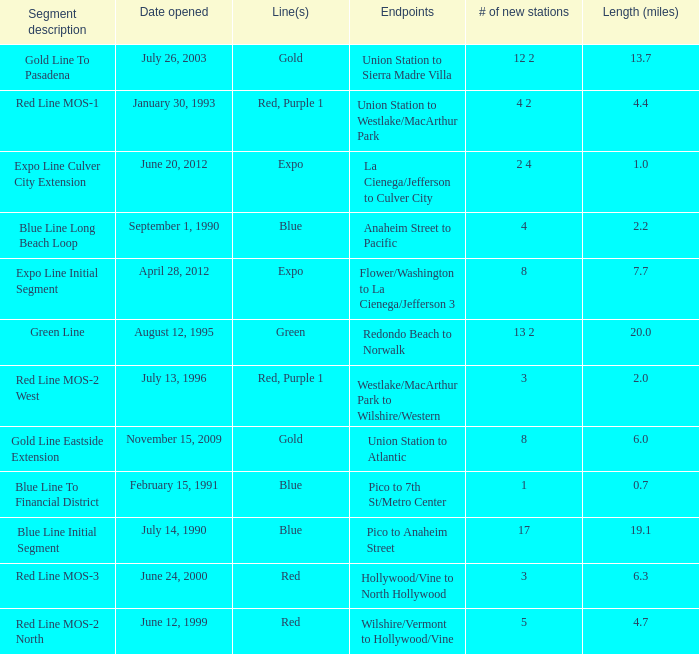How many new stations have a lenght (miles) of 6.0? 1.0. Would you mind parsing the complete table? {'header': ['Segment description', 'Date opened', 'Line(s)', 'Endpoints', '# of new stations', 'Length (miles)'], 'rows': [['Gold Line To Pasadena', 'July 26, 2003', 'Gold', 'Union Station to Sierra Madre Villa', '12 2', '13.7'], ['Red Line MOS-1', 'January 30, 1993', 'Red, Purple 1', 'Union Station to Westlake/MacArthur Park', '4 2', '4.4'], ['Expo Line Culver City Extension', 'June 20, 2012', 'Expo', 'La Cienega/Jefferson to Culver City', '2 4', '1.0'], ['Blue Line Long Beach Loop', 'September 1, 1990', 'Blue', 'Anaheim Street to Pacific', '4', '2.2'], ['Expo Line Initial Segment', 'April 28, 2012', 'Expo', 'Flower/Washington to La Cienega/Jefferson 3', '8', '7.7'], ['Green Line', 'August 12, 1995', 'Green', 'Redondo Beach to Norwalk', '13 2', '20.0'], ['Red Line MOS-2 West', 'July 13, 1996', 'Red, Purple 1', 'Westlake/MacArthur Park to Wilshire/Western', '3', '2.0'], ['Gold Line Eastside Extension', 'November 15, 2009', 'Gold', 'Union Station to Atlantic', '8', '6.0'], ['Blue Line To Financial District', 'February 15, 1991', 'Blue', 'Pico to 7th St/Metro Center', '1', '0.7'], ['Blue Line Initial Segment', 'July 14, 1990', 'Blue', 'Pico to Anaheim Street', '17', '19.1'], ['Red Line MOS-3', 'June 24, 2000', 'Red', 'Hollywood/Vine to North Hollywood', '3', '6.3'], ['Red Line MOS-2 North', 'June 12, 1999', 'Red', 'Wilshire/Vermont to Hollywood/Vine', '5', '4.7']]} 